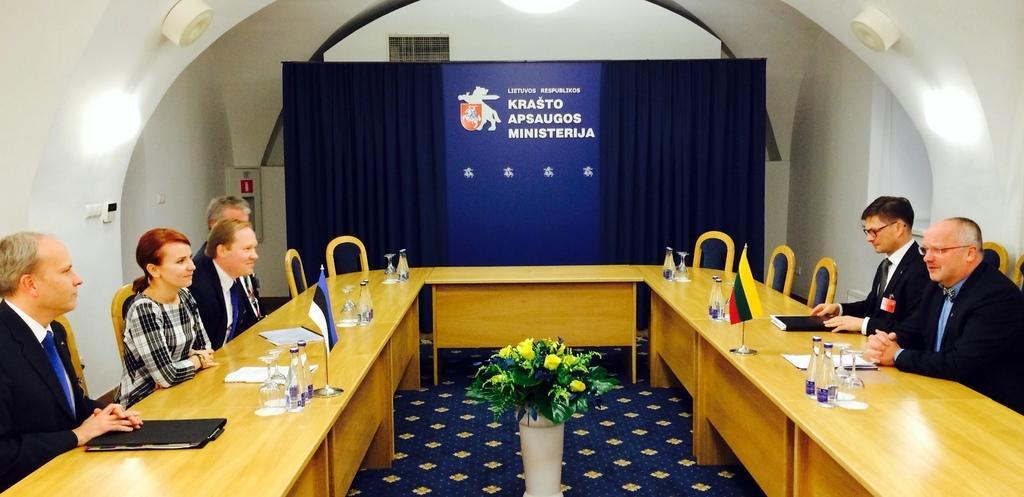In one or two sentences, can you explain what this image depicts? In this picture I can see few people sitting in the chairs and I can see water bottles, few glasses, papers and couple of files and couple of flags on the tables and I can see a flower pot in the middle and I can see a cloth in the back and looks like a hoarding with some text and I can see a light on the ceiling. 